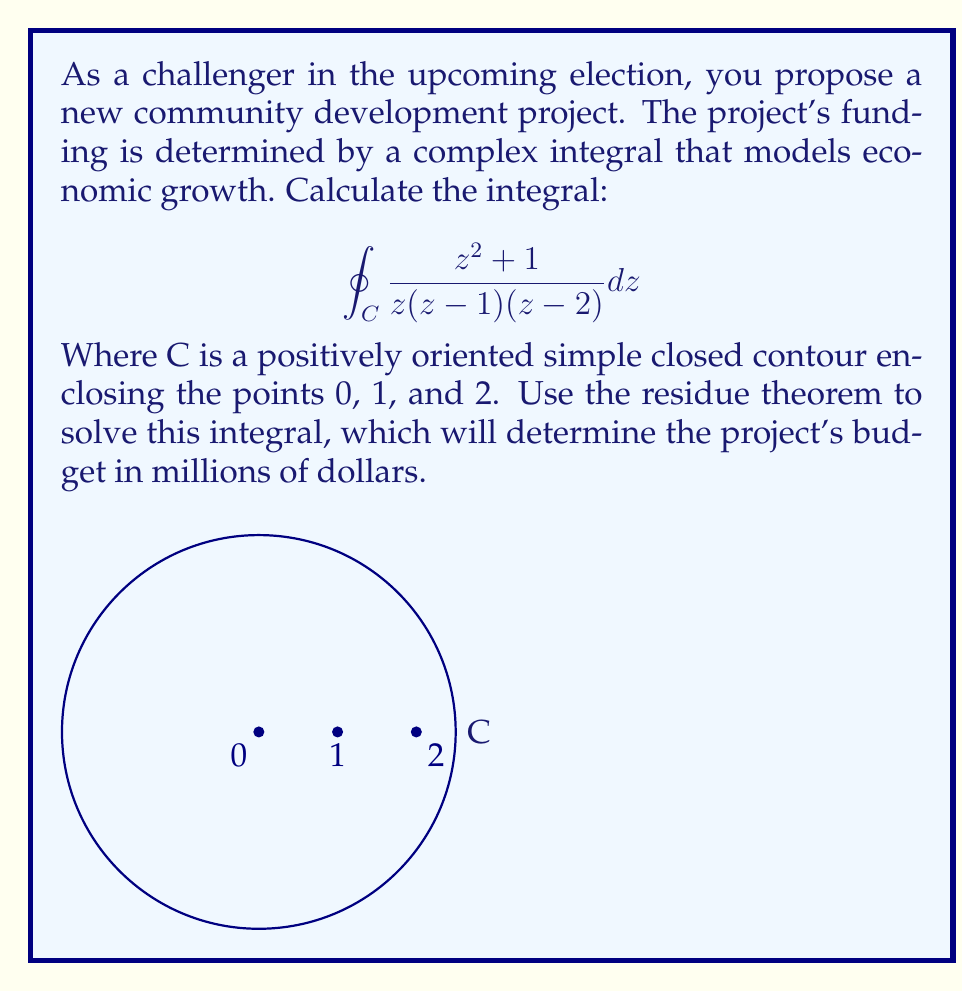Teach me how to tackle this problem. To solve this integral using the residue theorem, we follow these steps:

1) The residue theorem states that for a function $f(z)$ that is analytic except for isolated singularities inside a simple closed contour C:

   $$\oint_C f(z) dz = 2\pi i \sum_{k=1}^n \text{Res}[f(z), z_k]$$

   where $z_k$ are the singularities inside C.

2) In our case, $f(z) = \frac{z^2 + 1}{z(z-1)(z-2)}$ and we have three singularities: 0, 1, and 2.

3) Let's calculate the residues at each point:

   a) At $z = 0$ (simple pole):
      $$\text{Res}[f(z), 0] = \lim_{z \to 0} z \cdot \frac{z^2 + 1}{z(z-1)(z-2)} = \lim_{z \to 0} \frac{z^2 + 1}{(z-1)(z-2)} = \frac{1}{(-1)(-2)} = \frac{1}{2}$$

   b) At $z = 1$ (simple pole):
      $$\text{Res}[f(z), 1] = \lim_{z \to 1} (z-1) \cdot \frac{z^2 + 1}{z(z-1)(z-2)} = \lim_{z \to 1} \frac{z^2 + 1}{z(z-2)} = \frac{1^2 + 1}{1(1-2)} = -2$$

   c) At $z = 2$ (simple pole):
      $$\text{Res}[f(z), 2] = \lim_{z \to 2} (z-2) \cdot \frac{z^2 + 1}{z(z-1)(z-2)} = \lim_{z \to 2} \frac{z^2 + 1}{z(z-1)} = \frac{2^2 + 1}{2(2-1)} = \frac{5}{2}$$

4) Now we can apply the residue theorem:

   $$\oint_C \frac{z^2 + 1}{z(z-1)(z-2)} dz = 2\pi i (\frac{1}{2} + (-2) + \frac{5}{2}) = 2\pi i \cdot 1 = 2\pi i$$

Therefore, the value of the integral is $2\pi i$, which corresponds to a budget of $2\pi$ million dollars for the community development project.
Answer: $2\pi i$ 